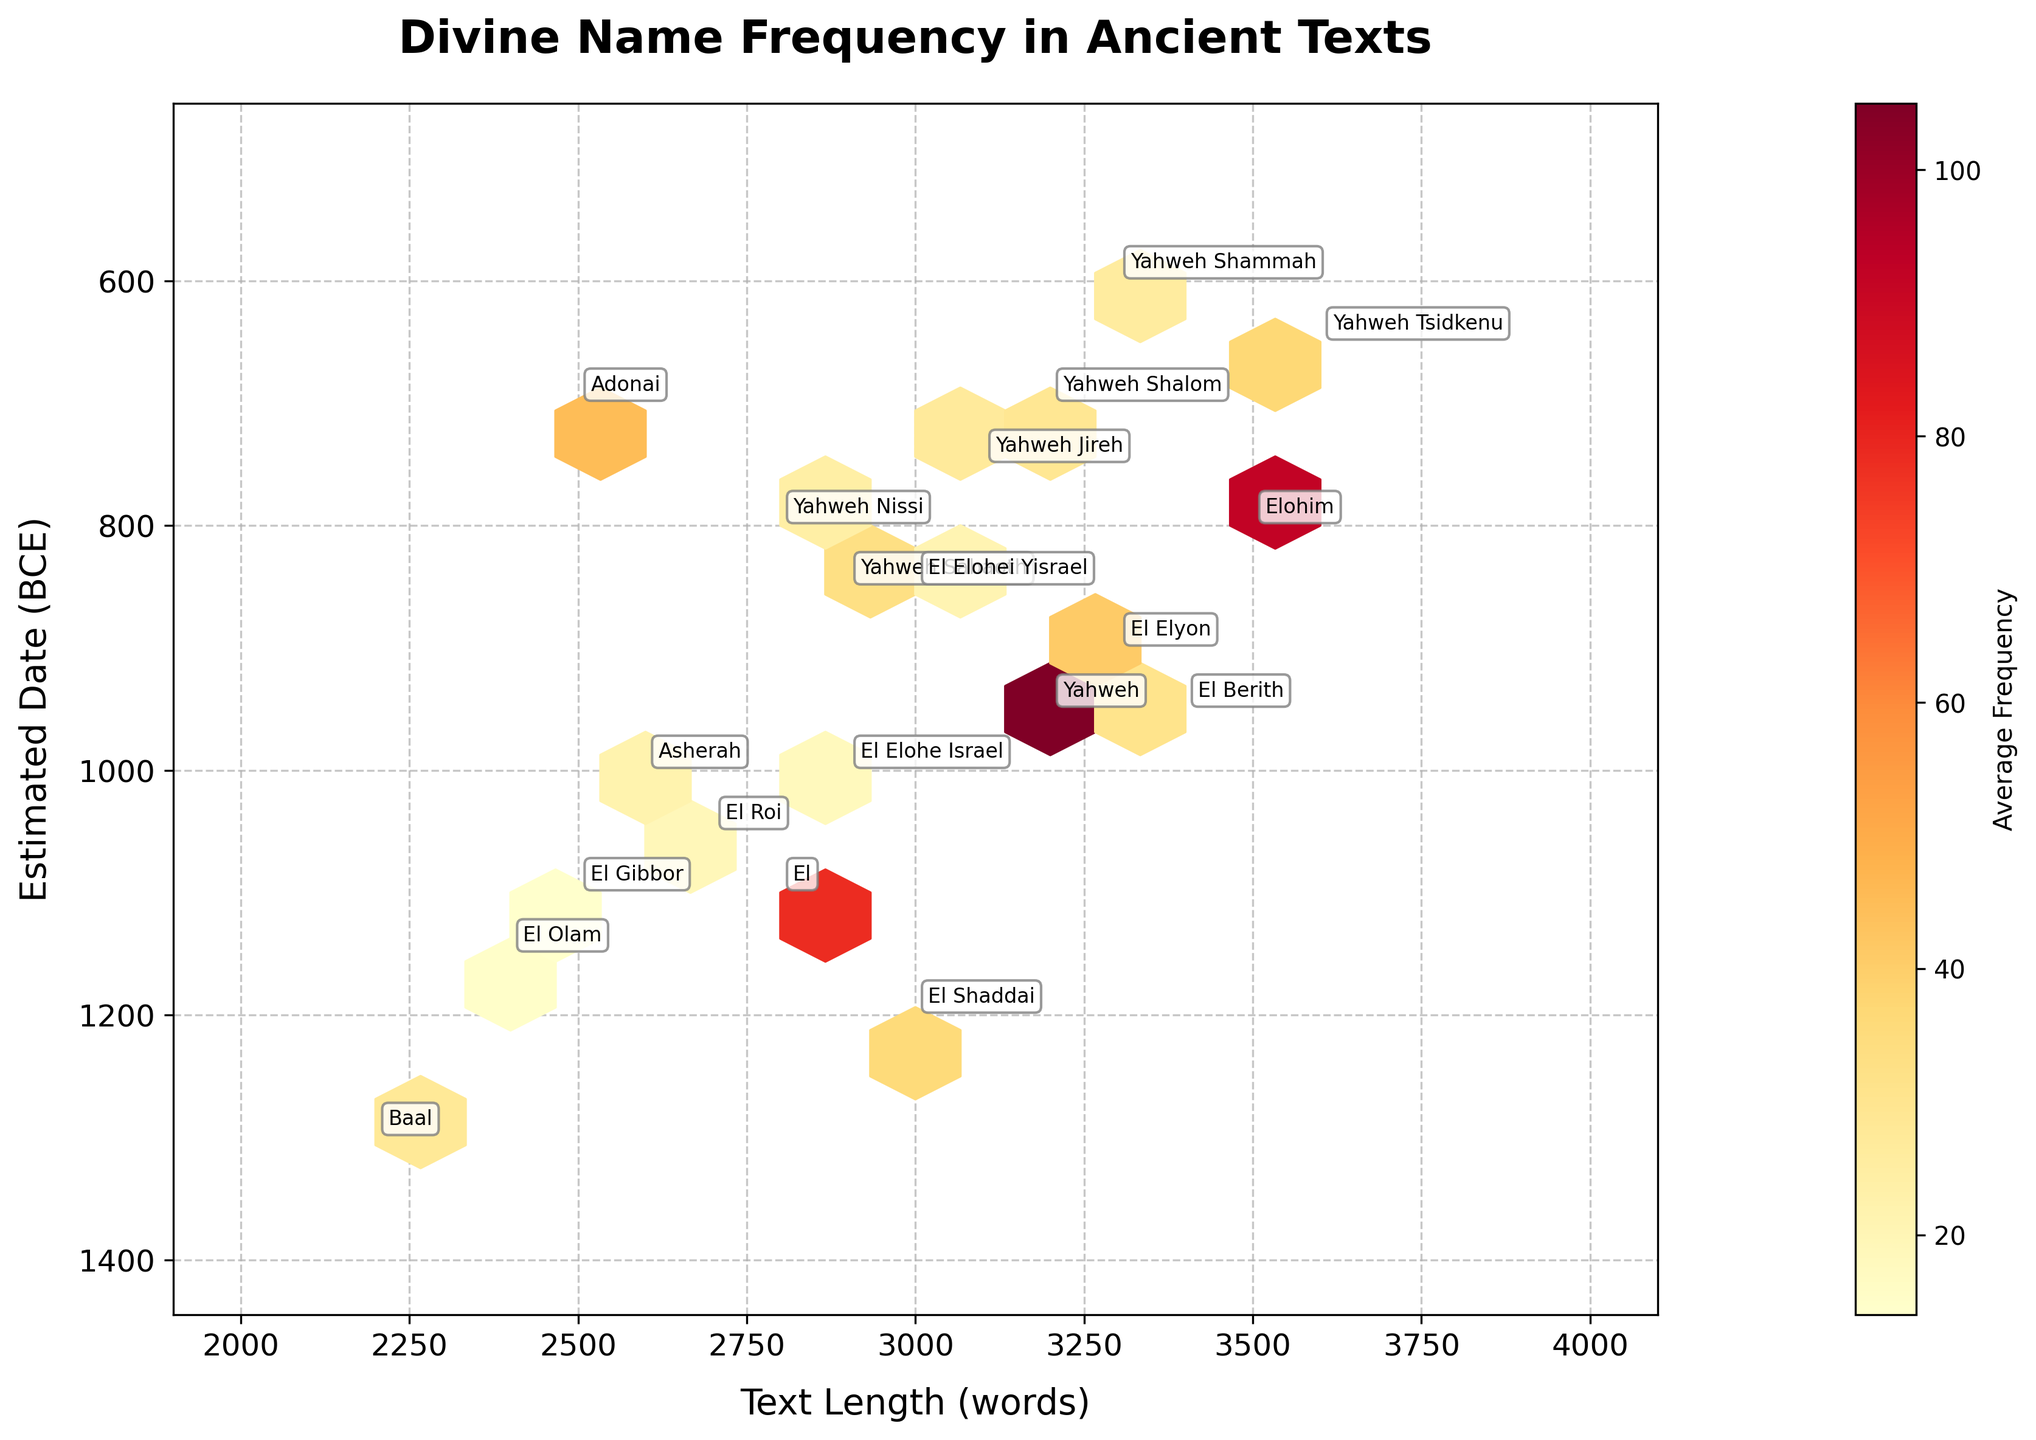What is the title of the figure? The title is located at the top of the figure, indicating the overarching topic that the plot addresses. Here, it clearly states "Divine Name Frequency in Ancient Texts."
Answer: Divine Name Frequency in Ancient Texts What are the labels on the x-axis and y-axis? The x-axis and y-axis labels describe the variables being measured on the horizontal and vertical axes, respectively. The x-axis is labeled "Text Length (words)," and the y-axis is labeled "Estimated Date (BCE)."
Answer: Text Length (words) and Estimated Date (BCE) Which divine name appears most frequently in the given texts? The figure uses a hexbin plot where regions with higher frequency are denoted by darker colors. By observing the color bar and annotations, we can see which divine name clusters in the darkest region. Yahweh, with a label near the hexbin of deepest color, appears most frequently.
Answer: Yahweh What is the range of text lengths (in words) covered by the figure? The range of text lengths can be determined by observing the x-axis, which shows the span of values from its minimum to maximum limit. The x-axis ranges approximately from 2000 to 4000 words.
Answer: 2000 to 4000 words What is the general trend regarding the estimated date (BCE) as text length increases? Looking at the hexbin plot, we can observe how hexagons cluster or disperse along the x and y axes. Generally, as the text length increases (moves right on the x-axis), the estimated date tends to be more recent (decreases on the y-axis).
Answer: More recent texts tend to be longer Which divine name has the highest average frequency for texts originating around 950 BCE? On the plot, locate the area around 950 BCE on the y-axis and note the darkest hexbin segment. Annotations help identify the divine name in that segment; Yahweh has the highest frequency in this area.
Answer: Yahweh Compare the frequency of "El" with "Baal". Which one is mentioned more and by how much? Locate the annotations for "El" and "Baal" on the plot and compare their frequencies indicated by the color intensity and numeric labels. El is mentioned more frequently than Baal, with El having a frequency of 78 and Baal having 28. The difference is 50.
Answer: El, by 50 What divine names have text lengths of approximately 2500 words? Find the x-axis value of 2500 words and check around this vertical line for annotations of divine names. Adonai and El Gibbor have text lengths close to 2500 words.
Answer: Adonai and El Gibbor Which divine name, originating around 700 BCE, is mentioned most frequently? Locate the 700 BCE mark on the y-axis and look for the darkest hexagon in this vicinity. An annotation identifies the name. Yahweh Shalom, located around 700 BCE, is mentioned most frequently in this period.
Answer: Yahweh Shalom For texts estimated from 1100 BCE, which divine name is associated with the highest frequency? Identify around 1100 BCE on the y-axis and locate the darkest hexagon in this area. The annotation next to this hexbin reveals "El," indicating it's the most frequent divine name for texts from this period.
Answer: El 